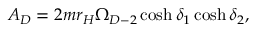Convert formula to latex. <formula><loc_0><loc_0><loc_500><loc_500>A _ { D } = 2 m r _ { H } \Omega _ { D - 2 } \cosh \delta _ { 1 } \cosh \delta _ { 2 } ,</formula> 